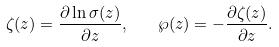<formula> <loc_0><loc_0><loc_500><loc_500>\zeta ( z ) = \frac { \partial \ln \sigma ( z ) } { \partial z } , \quad \wp ( z ) = - \frac { \partial \zeta ( z ) } { \partial z } .</formula> 